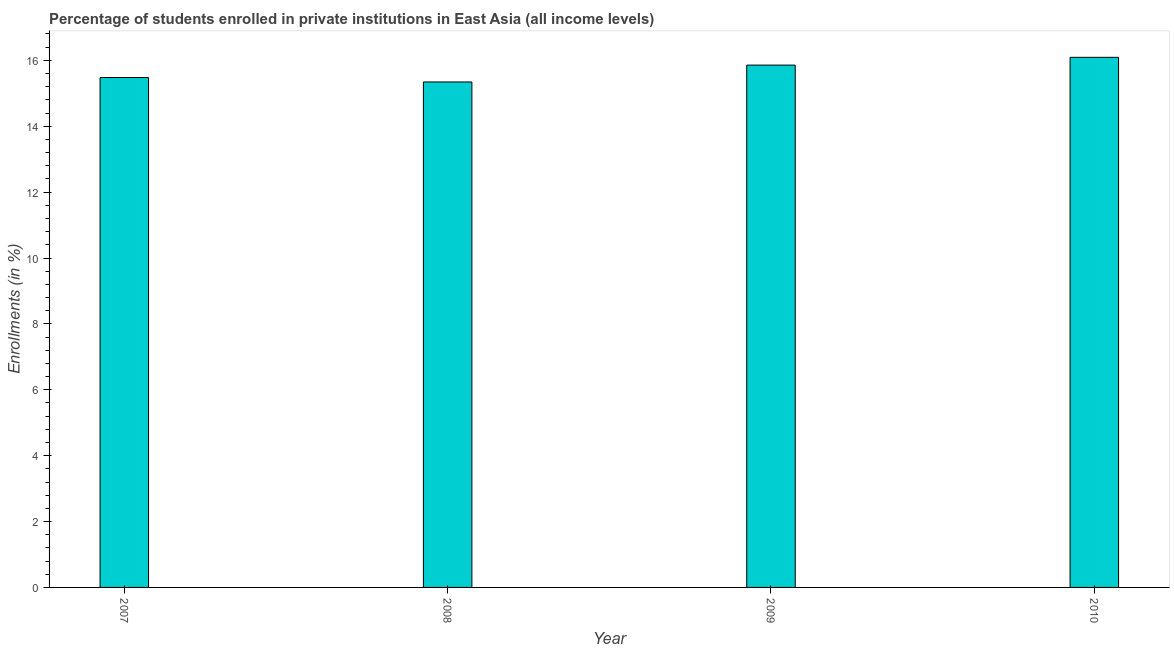Does the graph contain any zero values?
Give a very brief answer. No. Does the graph contain grids?
Give a very brief answer. No. What is the title of the graph?
Provide a short and direct response. Percentage of students enrolled in private institutions in East Asia (all income levels). What is the label or title of the X-axis?
Your answer should be very brief. Year. What is the label or title of the Y-axis?
Make the answer very short. Enrollments (in %). What is the enrollments in private institutions in 2010?
Your answer should be compact. 16.09. Across all years, what is the maximum enrollments in private institutions?
Provide a succinct answer. 16.09. Across all years, what is the minimum enrollments in private institutions?
Give a very brief answer. 15.34. In which year was the enrollments in private institutions minimum?
Ensure brevity in your answer.  2008. What is the sum of the enrollments in private institutions?
Ensure brevity in your answer.  62.77. What is the difference between the enrollments in private institutions in 2008 and 2009?
Offer a very short reply. -0.51. What is the average enrollments in private institutions per year?
Make the answer very short. 15.69. What is the median enrollments in private institutions?
Your response must be concise. 15.67. What is the ratio of the enrollments in private institutions in 2008 to that in 2010?
Provide a short and direct response. 0.95. What is the difference between the highest and the second highest enrollments in private institutions?
Keep it short and to the point. 0.24. What is the difference between the highest and the lowest enrollments in private institutions?
Provide a short and direct response. 0.75. In how many years, is the enrollments in private institutions greater than the average enrollments in private institutions taken over all years?
Make the answer very short. 2. Are all the bars in the graph horizontal?
Provide a short and direct response. No. What is the Enrollments (in %) in 2007?
Provide a succinct answer. 15.48. What is the Enrollments (in %) of 2008?
Offer a very short reply. 15.34. What is the Enrollments (in %) in 2009?
Offer a terse response. 15.86. What is the Enrollments (in %) in 2010?
Provide a succinct answer. 16.09. What is the difference between the Enrollments (in %) in 2007 and 2008?
Ensure brevity in your answer.  0.13. What is the difference between the Enrollments (in %) in 2007 and 2009?
Offer a very short reply. -0.38. What is the difference between the Enrollments (in %) in 2007 and 2010?
Make the answer very short. -0.61. What is the difference between the Enrollments (in %) in 2008 and 2009?
Your answer should be very brief. -0.51. What is the difference between the Enrollments (in %) in 2008 and 2010?
Provide a short and direct response. -0.75. What is the difference between the Enrollments (in %) in 2009 and 2010?
Your answer should be compact. -0.24. What is the ratio of the Enrollments (in %) in 2007 to that in 2008?
Give a very brief answer. 1.01. What is the ratio of the Enrollments (in %) in 2007 to that in 2009?
Offer a terse response. 0.98. What is the ratio of the Enrollments (in %) in 2007 to that in 2010?
Ensure brevity in your answer.  0.96. What is the ratio of the Enrollments (in %) in 2008 to that in 2009?
Your answer should be very brief. 0.97. What is the ratio of the Enrollments (in %) in 2008 to that in 2010?
Provide a succinct answer. 0.95. 